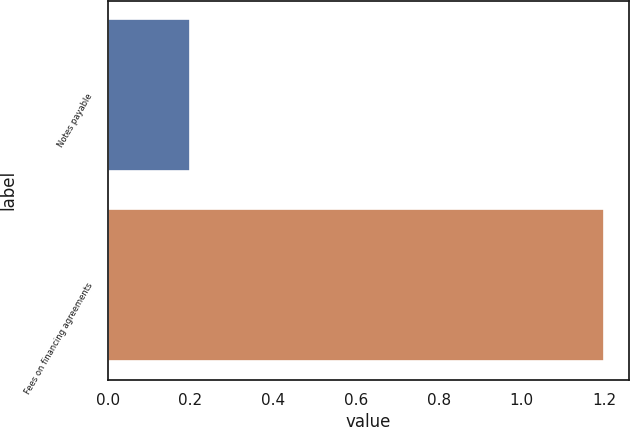<chart> <loc_0><loc_0><loc_500><loc_500><bar_chart><fcel>Notes payable<fcel>Fees on financing agreements<nl><fcel>0.2<fcel>1.2<nl></chart> 